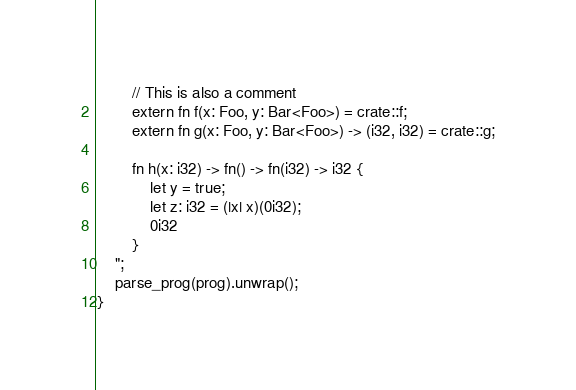<code> <loc_0><loc_0><loc_500><loc_500><_Rust_>        // This is also a comment
        extern fn f(x: Foo, y: Bar<Foo>) = crate::f;
        extern fn g(x: Foo, y: Bar<Foo>) -> (i32, i32) = crate::g;

        fn h(x: i32) -> fn() -> fn(i32) -> i32 {
            let y = true;
            let z: i32 = (|x| x)(0i32);
            0i32
        }
    ";
    parse_prog(prog).unwrap();
}
</code> 